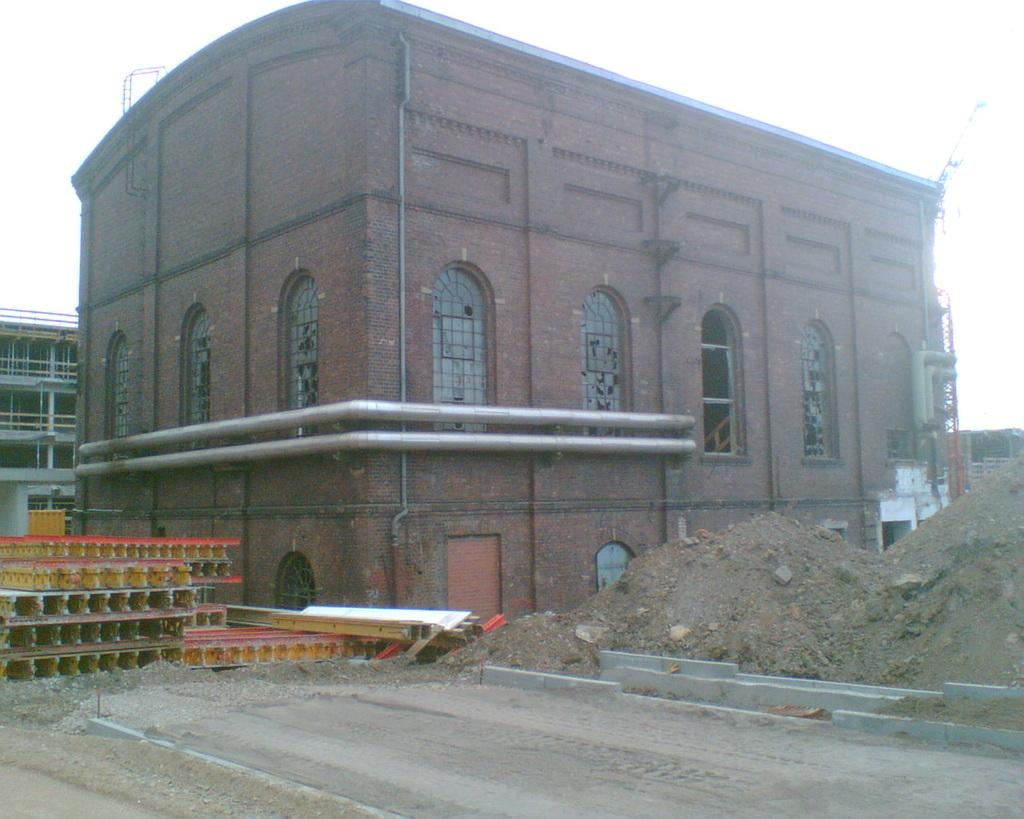What type of structures are visible in the image? There are buildings in the image. What can be seen on the buildings? There are pipes on the buildings. What other objects are present near the buildings? There are metal rods beside the buildings. How do the boys in the image express their fear of the metal rods? There are no boys present in the image, so their fear of the metal rods cannot be observed. 